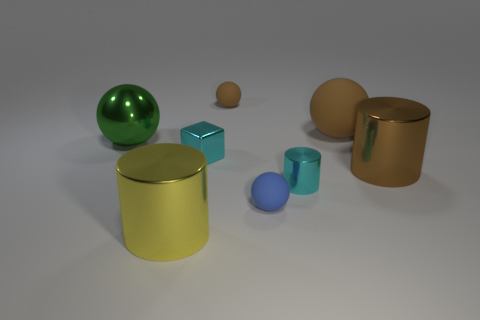How many other objects are the same shape as the big yellow thing?
Offer a very short reply. 2. There is a object that is to the left of the yellow cylinder; is it the same size as the rubber object in front of the green metal ball?
Your answer should be very brief. No. What number of cylinders are either brown metal things or yellow things?
Your answer should be very brief. 2. How many matte objects are green things or big yellow cylinders?
Your response must be concise. 0. There is a green shiny thing that is the same shape as the big brown rubber thing; what size is it?
Provide a short and direct response. Large. There is a cyan cylinder; is it the same size as the cyan metal thing on the left side of the tiny shiny cylinder?
Offer a very short reply. Yes. What shape is the cyan metal thing to the right of the small blue rubber thing?
Make the answer very short. Cylinder. What color is the large metallic cylinder that is right of the tiny brown rubber ball behind the cyan metallic cylinder?
Ensure brevity in your answer.  Brown. What is the color of the other big thing that is the same shape as the green thing?
Provide a succinct answer. Brown. How many things have the same color as the small metallic cube?
Provide a short and direct response. 1. 